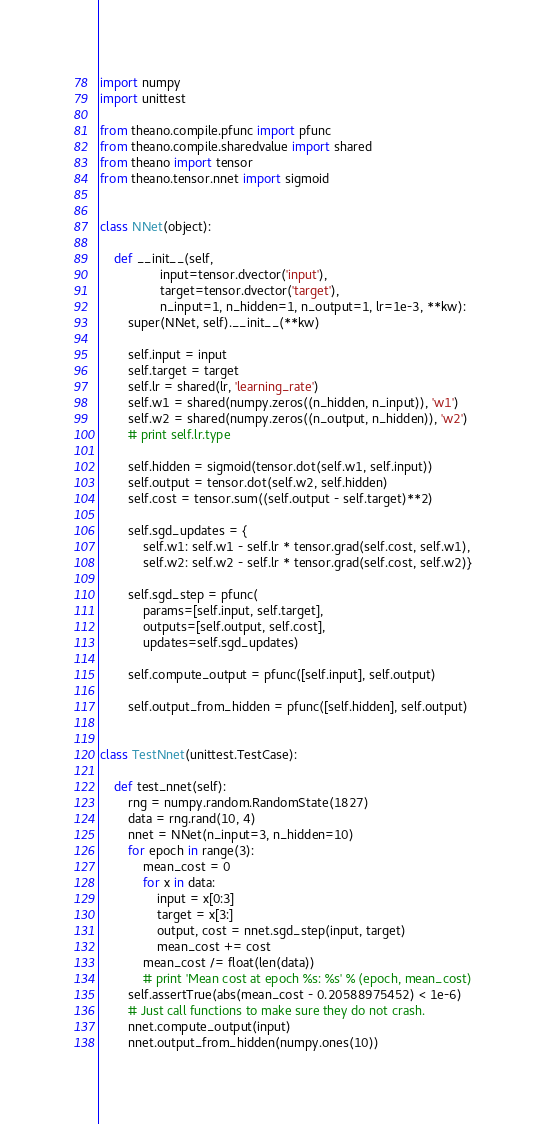Convert code to text. <code><loc_0><loc_0><loc_500><loc_500><_Python_>import numpy
import unittest

from theano.compile.pfunc import pfunc
from theano.compile.sharedvalue import shared
from theano import tensor
from theano.tensor.nnet import sigmoid


class NNet(object):

    def __init__(self,
                 input=tensor.dvector('input'),
                 target=tensor.dvector('target'),
                 n_input=1, n_hidden=1, n_output=1, lr=1e-3, **kw):
        super(NNet, self).__init__(**kw)

        self.input = input
        self.target = target
        self.lr = shared(lr, 'learning_rate')
        self.w1 = shared(numpy.zeros((n_hidden, n_input)), 'w1')
        self.w2 = shared(numpy.zeros((n_output, n_hidden)), 'w2')
        # print self.lr.type

        self.hidden = sigmoid(tensor.dot(self.w1, self.input))
        self.output = tensor.dot(self.w2, self.hidden)
        self.cost = tensor.sum((self.output - self.target)**2)

        self.sgd_updates = {
            self.w1: self.w1 - self.lr * tensor.grad(self.cost, self.w1),
            self.w2: self.w2 - self.lr * tensor.grad(self.cost, self.w2)}

        self.sgd_step = pfunc(
            params=[self.input, self.target],
            outputs=[self.output, self.cost],
            updates=self.sgd_updates)

        self.compute_output = pfunc([self.input], self.output)

        self.output_from_hidden = pfunc([self.hidden], self.output)


class TestNnet(unittest.TestCase):

    def test_nnet(self):
        rng = numpy.random.RandomState(1827)
        data = rng.rand(10, 4)
        nnet = NNet(n_input=3, n_hidden=10)
        for epoch in range(3):
            mean_cost = 0
            for x in data:
                input = x[0:3]
                target = x[3:]
                output, cost = nnet.sgd_step(input, target)
                mean_cost += cost
            mean_cost /= float(len(data))
            # print 'Mean cost at epoch %s: %s' % (epoch, mean_cost)
        self.assertTrue(abs(mean_cost - 0.20588975452) < 1e-6)
        # Just call functions to make sure they do not crash.
        nnet.compute_output(input)
        nnet.output_from_hidden(numpy.ones(10))
</code> 